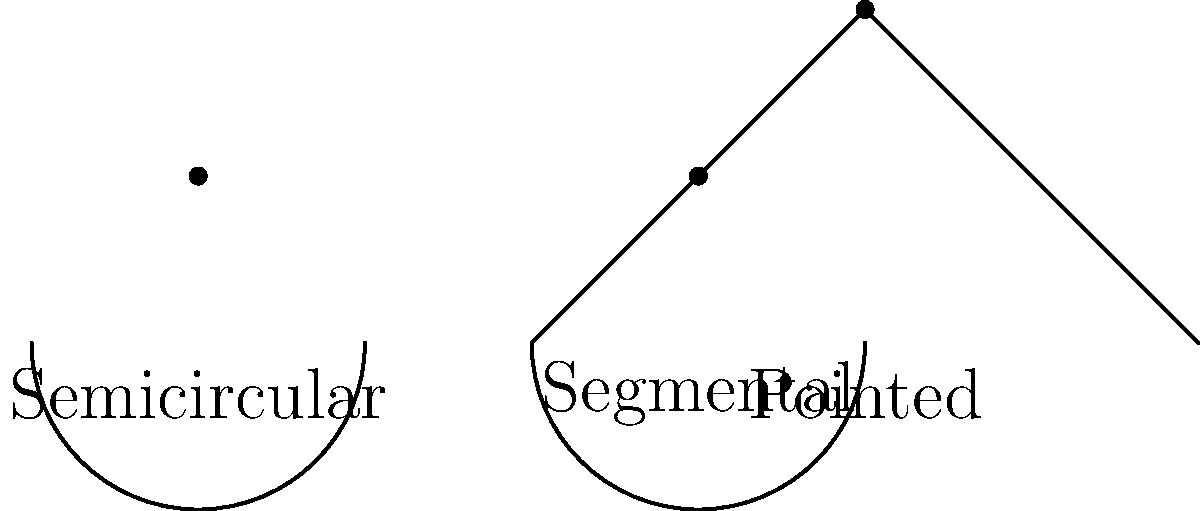In bricklaying, different types of arches are used for various architectural styles. The image shows three common types of arches: semicircular, segmental, and pointed. Which of these arches has the highest order of rotational symmetry, and what is that order? To determine the order of rotational symmetry for each arch, we need to consider how many times the arch can be rotated around its center point to produce an identical appearance. Let's analyze each arch:

1. Semicircular arch:
   - This arch forms a perfect half-circle.
   - It has infinite rotational symmetry around its center point.
   - The order of rotational symmetry is considered to be $\infty$.

2. Segmental arch:
   - This arch is a segment of a circle, less than a semicircle.
   - It has only one rotation that produces an identical appearance (360°).
   - The order of rotational symmetry is 1.

3. Pointed arch:
   - This arch consists of two curved segments meeting at a point.
   - It has two rotations that produce an identical appearance (180° and 360°).
   - The order of rotational symmetry is 2.

Among these three arches, the semicircular arch has the highest order of rotational symmetry, which is $\infty$.
Answer: Semicircular arch, $\infty$ 